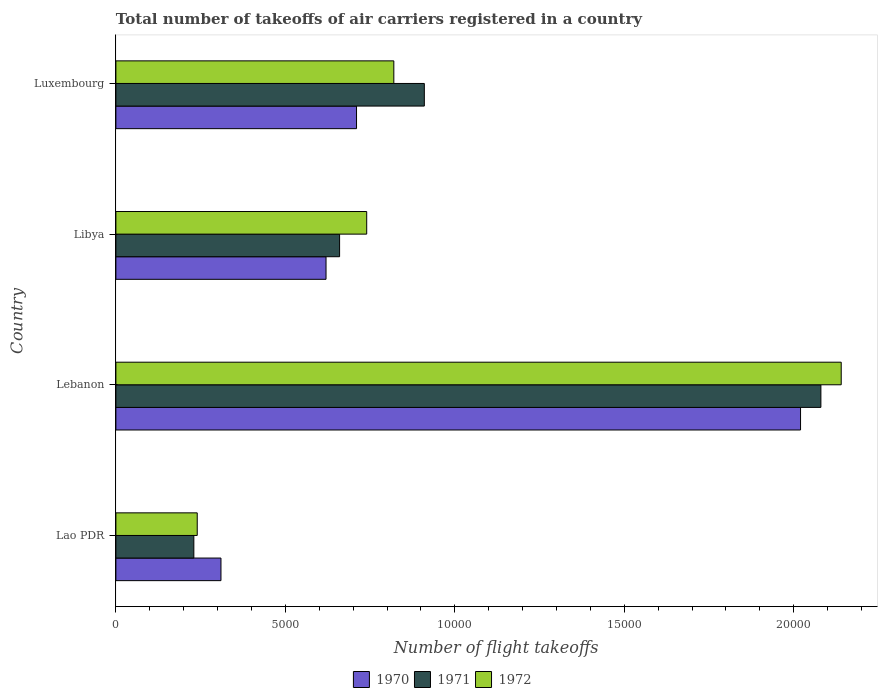How many groups of bars are there?
Your answer should be compact. 4. Are the number of bars on each tick of the Y-axis equal?
Provide a short and direct response. Yes. What is the label of the 4th group of bars from the top?
Offer a terse response. Lao PDR. What is the total number of flight takeoffs in 1971 in Libya?
Your response must be concise. 6600. Across all countries, what is the maximum total number of flight takeoffs in 1970?
Keep it short and to the point. 2.02e+04. Across all countries, what is the minimum total number of flight takeoffs in 1972?
Make the answer very short. 2400. In which country was the total number of flight takeoffs in 1972 maximum?
Your response must be concise. Lebanon. In which country was the total number of flight takeoffs in 1971 minimum?
Keep it short and to the point. Lao PDR. What is the total total number of flight takeoffs in 1972 in the graph?
Offer a terse response. 3.94e+04. What is the difference between the total number of flight takeoffs in 1971 in Lao PDR and that in Libya?
Keep it short and to the point. -4300. What is the difference between the total number of flight takeoffs in 1971 in Luxembourg and the total number of flight takeoffs in 1972 in Lebanon?
Provide a short and direct response. -1.23e+04. What is the average total number of flight takeoffs in 1971 per country?
Offer a terse response. 9700. What is the difference between the total number of flight takeoffs in 1970 and total number of flight takeoffs in 1971 in Luxembourg?
Ensure brevity in your answer.  -2000. What is the ratio of the total number of flight takeoffs in 1970 in Libya to that in Luxembourg?
Make the answer very short. 0.87. What is the difference between the highest and the second highest total number of flight takeoffs in 1972?
Ensure brevity in your answer.  1.32e+04. What is the difference between the highest and the lowest total number of flight takeoffs in 1971?
Give a very brief answer. 1.85e+04. In how many countries, is the total number of flight takeoffs in 1971 greater than the average total number of flight takeoffs in 1971 taken over all countries?
Give a very brief answer. 1. Is the sum of the total number of flight takeoffs in 1972 in Libya and Luxembourg greater than the maximum total number of flight takeoffs in 1971 across all countries?
Provide a short and direct response. No. What does the 2nd bar from the top in Libya represents?
Offer a very short reply. 1971. Is it the case that in every country, the sum of the total number of flight takeoffs in 1971 and total number of flight takeoffs in 1970 is greater than the total number of flight takeoffs in 1972?
Your response must be concise. Yes. Are all the bars in the graph horizontal?
Provide a short and direct response. Yes. How many countries are there in the graph?
Offer a terse response. 4. Where does the legend appear in the graph?
Offer a very short reply. Bottom center. How many legend labels are there?
Offer a terse response. 3. What is the title of the graph?
Your response must be concise. Total number of takeoffs of air carriers registered in a country. Does "1980" appear as one of the legend labels in the graph?
Provide a short and direct response. No. What is the label or title of the X-axis?
Your response must be concise. Number of flight takeoffs. What is the Number of flight takeoffs in 1970 in Lao PDR?
Provide a succinct answer. 3100. What is the Number of flight takeoffs of 1971 in Lao PDR?
Offer a terse response. 2300. What is the Number of flight takeoffs of 1972 in Lao PDR?
Provide a succinct answer. 2400. What is the Number of flight takeoffs in 1970 in Lebanon?
Your answer should be very brief. 2.02e+04. What is the Number of flight takeoffs of 1971 in Lebanon?
Give a very brief answer. 2.08e+04. What is the Number of flight takeoffs of 1972 in Lebanon?
Keep it short and to the point. 2.14e+04. What is the Number of flight takeoffs of 1970 in Libya?
Offer a terse response. 6200. What is the Number of flight takeoffs of 1971 in Libya?
Offer a terse response. 6600. What is the Number of flight takeoffs in 1972 in Libya?
Your response must be concise. 7400. What is the Number of flight takeoffs in 1970 in Luxembourg?
Keep it short and to the point. 7100. What is the Number of flight takeoffs of 1971 in Luxembourg?
Your response must be concise. 9100. What is the Number of flight takeoffs in 1972 in Luxembourg?
Provide a short and direct response. 8200. Across all countries, what is the maximum Number of flight takeoffs of 1970?
Make the answer very short. 2.02e+04. Across all countries, what is the maximum Number of flight takeoffs of 1971?
Your answer should be very brief. 2.08e+04. Across all countries, what is the maximum Number of flight takeoffs in 1972?
Give a very brief answer. 2.14e+04. Across all countries, what is the minimum Number of flight takeoffs in 1970?
Your answer should be compact. 3100. Across all countries, what is the minimum Number of flight takeoffs in 1971?
Keep it short and to the point. 2300. Across all countries, what is the minimum Number of flight takeoffs in 1972?
Your response must be concise. 2400. What is the total Number of flight takeoffs in 1970 in the graph?
Provide a succinct answer. 3.66e+04. What is the total Number of flight takeoffs in 1971 in the graph?
Your response must be concise. 3.88e+04. What is the total Number of flight takeoffs of 1972 in the graph?
Offer a very short reply. 3.94e+04. What is the difference between the Number of flight takeoffs in 1970 in Lao PDR and that in Lebanon?
Provide a short and direct response. -1.71e+04. What is the difference between the Number of flight takeoffs of 1971 in Lao PDR and that in Lebanon?
Offer a very short reply. -1.85e+04. What is the difference between the Number of flight takeoffs in 1972 in Lao PDR and that in Lebanon?
Offer a very short reply. -1.90e+04. What is the difference between the Number of flight takeoffs of 1970 in Lao PDR and that in Libya?
Your response must be concise. -3100. What is the difference between the Number of flight takeoffs in 1971 in Lao PDR and that in Libya?
Your response must be concise. -4300. What is the difference between the Number of flight takeoffs in 1972 in Lao PDR and that in Libya?
Give a very brief answer. -5000. What is the difference between the Number of flight takeoffs of 1970 in Lao PDR and that in Luxembourg?
Provide a short and direct response. -4000. What is the difference between the Number of flight takeoffs in 1971 in Lao PDR and that in Luxembourg?
Provide a short and direct response. -6800. What is the difference between the Number of flight takeoffs in 1972 in Lao PDR and that in Luxembourg?
Offer a very short reply. -5800. What is the difference between the Number of flight takeoffs in 1970 in Lebanon and that in Libya?
Ensure brevity in your answer.  1.40e+04. What is the difference between the Number of flight takeoffs in 1971 in Lebanon and that in Libya?
Offer a terse response. 1.42e+04. What is the difference between the Number of flight takeoffs in 1972 in Lebanon and that in Libya?
Provide a short and direct response. 1.40e+04. What is the difference between the Number of flight takeoffs of 1970 in Lebanon and that in Luxembourg?
Keep it short and to the point. 1.31e+04. What is the difference between the Number of flight takeoffs in 1971 in Lebanon and that in Luxembourg?
Keep it short and to the point. 1.17e+04. What is the difference between the Number of flight takeoffs of 1972 in Lebanon and that in Luxembourg?
Make the answer very short. 1.32e+04. What is the difference between the Number of flight takeoffs in 1970 in Libya and that in Luxembourg?
Provide a succinct answer. -900. What is the difference between the Number of flight takeoffs of 1971 in Libya and that in Luxembourg?
Keep it short and to the point. -2500. What is the difference between the Number of flight takeoffs of 1972 in Libya and that in Luxembourg?
Your response must be concise. -800. What is the difference between the Number of flight takeoffs in 1970 in Lao PDR and the Number of flight takeoffs in 1971 in Lebanon?
Provide a short and direct response. -1.77e+04. What is the difference between the Number of flight takeoffs in 1970 in Lao PDR and the Number of flight takeoffs in 1972 in Lebanon?
Ensure brevity in your answer.  -1.83e+04. What is the difference between the Number of flight takeoffs in 1971 in Lao PDR and the Number of flight takeoffs in 1972 in Lebanon?
Make the answer very short. -1.91e+04. What is the difference between the Number of flight takeoffs of 1970 in Lao PDR and the Number of flight takeoffs of 1971 in Libya?
Keep it short and to the point. -3500. What is the difference between the Number of flight takeoffs in 1970 in Lao PDR and the Number of flight takeoffs in 1972 in Libya?
Ensure brevity in your answer.  -4300. What is the difference between the Number of flight takeoffs in 1971 in Lao PDR and the Number of flight takeoffs in 1972 in Libya?
Provide a short and direct response. -5100. What is the difference between the Number of flight takeoffs in 1970 in Lao PDR and the Number of flight takeoffs in 1971 in Luxembourg?
Your answer should be very brief. -6000. What is the difference between the Number of flight takeoffs in 1970 in Lao PDR and the Number of flight takeoffs in 1972 in Luxembourg?
Give a very brief answer. -5100. What is the difference between the Number of flight takeoffs in 1971 in Lao PDR and the Number of flight takeoffs in 1972 in Luxembourg?
Give a very brief answer. -5900. What is the difference between the Number of flight takeoffs in 1970 in Lebanon and the Number of flight takeoffs in 1971 in Libya?
Ensure brevity in your answer.  1.36e+04. What is the difference between the Number of flight takeoffs in 1970 in Lebanon and the Number of flight takeoffs in 1972 in Libya?
Your answer should be compact. 1.28e+04. What is the difference between the Number of flight takeoffs in 1971 in Lebanon and the Number of flight takeoffs in 1972 in Libya?
Offer a terse response. 1.34e+04. What is the difference between the Number of flight takeoffs of 1970 in Lebanon and the Number of flight takeoffs of 1971 in Luxembourg?
Offer a terse response. 1.11e+04. What is the difference between the Number of flight takeoffs in 1970 in Lebanon and the Number of flight takeoffs in 1972 in Luxembourg?
Offer a very short reply. 1.20e+04. What is the difference between the Number of flight takeoffs in 1971 in Lebanon and the Number of flight takeoffs in 1972 in Luxembourg?
Ensure brevity in your answer.  1.26e+04. What is the difference between the Number of flight takeoffs of 1970 in Libya and the Number of flight takeoffs of 1971 in Luxembourg?
Ensure brevity in your answer.  -2900. What is the difference between the Number of flight takeoffs in 1970 in Libya and the Number of flight takeoffs in 1972 in Luxembourg?
Your response must be concise. -2000. What is the difference between the Number of flight takeoffs in 1971 in Libya and the Number of flight takeoffs in 1972 in Luxembourg?
Keep it short and to the point. -1600. What is the average Number of flight takeoffs in 1970 per country?
Give a very brief answer. 9150. What is the average Number of flight takeoffs in 1971 per country?
Your answer should be compact. 9700. What is the average Number of flight takeoffs of 1972 per country?
Your response must be concise. 9850. What is the difference between the Number of flight takeoffs in 1970 and Number of flight takeoffs in 1971 in Lao PDR?
Make the answer very short. 800. What is the difference between the Number of flight takeoffs of 1970 and Number of flight takeoffs of 1972 in Lao PDR?
Your answer should be very brief. 700. What is the difference between the Number of flight takeoffs of 1971 and Number of flight takeoffs of 1972 in Lao PDR?
Your answer should be very brief. -100. What is the difference between the Number of flight takeoffs in 1970 and Number of flight takeoffs in 1971 in Lebanon?
Keep it short and to the point. -600. What is the difference between the Number of flight takeoffs of 1970 and Number of flight takeoffs of 1972 in Lebanon?
Offer a terse response. -1200. What is the difference between the Number of flight takeoffs in 1971 and Number of flight takeoffs in 1972 in Lebanon?
Ensure brevity in your answer.  -600. What is the difference between the Number of flight takeoffs of 1970 and Number of flight takeoffs of 1971 in Libya?
Offer a very short reply. -400. What is the difference between the Number of flight takeoffs in 1970 and Number of flight takeoffs in 1972 in Libya?
Keep it short and to the point. -1200. What is the difference between the Number of flight takeoffs of 1971 and Number of flight takeoffs of 1972 in Libya?
Your answer should be very brief. -800. What is the difference between the Number of flight takeoffs of 1970 and Number of flight takeoffs of 1971 in Luxembourg?
Make the answer very short. -2000. What is the difference between the Number of flight takeoffs of 1970 and Number of flight takeoffs of 1972 in Luxembourg?
Provide a succinct answer. -1100. What is the difference between the Number of flight takeoffs of 1971 and Number of flight takeoffs of 1972 in Luxembourg?
Make the answer very short. 900. What is the ratio of the Number of flight takeoffs in 1970 in Lao PDR to that in Lebanon?
Ensure brevity in your answer.  0.15. What is the ratio of the Number of flight takeoffs of 1971 in Lao PDR to that in Lebanon?
Offer a very short reply. 0.11. What is the ratio of the Number of flight takeoffs of 1972 in Lao PDR to that in Lebanon?
Offer a terse response. 0.11. What is the ratio of the Number of flight takeoffs of 1970 in Lao PDR to that in Libya?
Give a very brief answer. 0.5. What is the ratio of the Number of flight takeoffs in 1971 in Lao PDR to that in Libya?
Keep it short and to the point. 0.35. What is the ratio of the Number of flight takeoffs of 1972 in Lao PDR to that in Libya?
Offer a terse response. 0.32. What is the ratio of the Number of flight takeoffs of 1970 in Lao PDR to that in Luxembourg?
Offer a very short reply. 0.44. What is the ratio of the Number of flight takeoffs of 1971 in Lao PDR to that in Luxembourg?
Offer a terse response. 0.25. What is the ratio of the Number of flight takeoffs in 1972 in Lao PDR to that in Luxembourg?
Keep it short and to the point. 0.29. What is the ratio of the Number of flight takeoffs of 1970 in Lebanon to that in Libya?
Your answer should be very brief. 3.26. What is the ratio of the Number of flight takeoffs in 1971 in Lebanon to that in Libya?
Your response must be concise. 3.15. What is the ratio of the Number of flight takeoffs of 1972 in Lebanon to that in Libya?
Provide a succinct answer. 2.89. What is the ratio of the Number of flight takeoffs of 1970 in Lebanon to that in Luxembourg?
Make the answer very short. 2.85. What is the ratio of the Number of flight takeoffs in 1971 in Lebanon to that in Luxembourg?
Provide a short and direct response. 2.29. What is the ratio of the Number of flight takeoffs of 1972 in Lebanon to that in Luxembourg?
Keep it short and to the point. 2.61. What is the ratio of the Number of flight takeoffs in 1970 in Libya to that in Luxembourg?
Your answer should be compact. 0.87. What is the ratio of the Number of flight takeoffs in 1971 in Libya to that in Luxembourg?
Your answer should be very brief. 0.73. What is the ratio of the Number of flight takeoffs of 1972 in Libya to that in Luxembourg?
Your answer should be compact. 0.9. What is the difference between the highest and the second highest Number of flight takeoffs in 1970?
Give a very brief answer. 1.31e+04. What is the difference between the highest and the second highest Number of flight takeoffs in 1971?
Ensure brevity in your answer.  1.17e+04. What is the difference between the highest and the second highest Number of flight takeoffs in 1972?
Your answer should be very brief. 1.32e+04. What is the difference between the highest and the lowest Number of flight takeoffs of 1970?
Offer a very short reply. 1.71e+04. What is the difference between the highest and the lowest Number of flight takeoffs in 1971?
Give a very brief answer. 1.85e+04. What is the difference between the highest and the lowest Number of flight takeoffs in 1972?
Ensure brevity in your answer.  1.90e+04. 